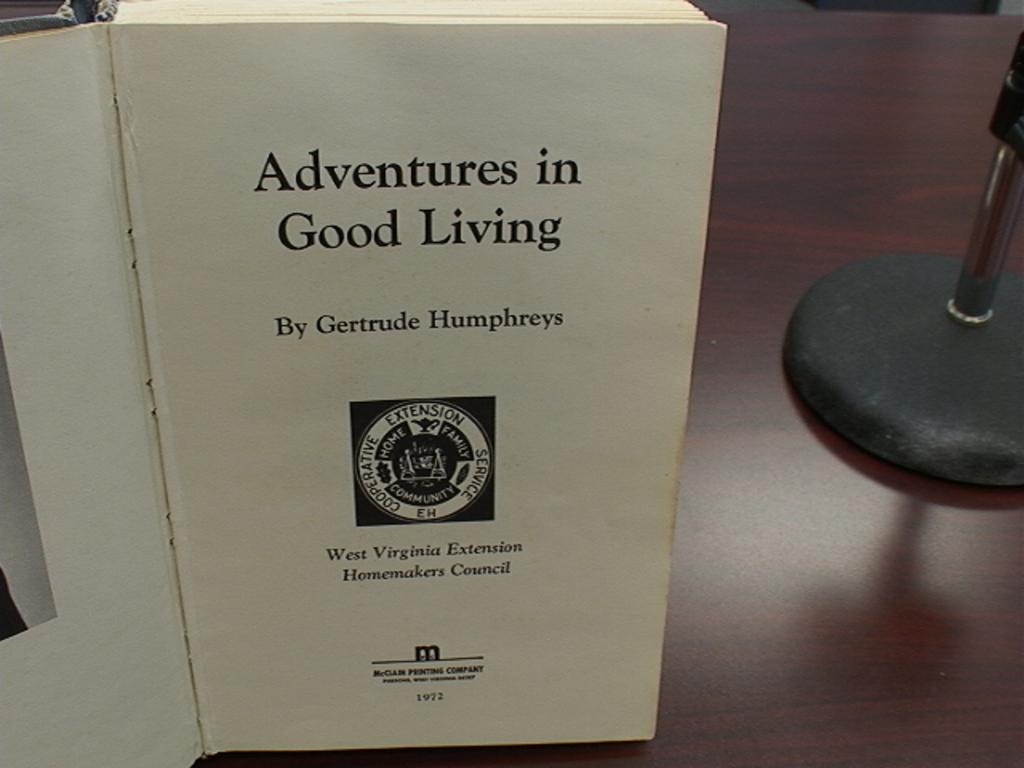What is the title of the story?
Offer a terse response. Adventures in good living. 